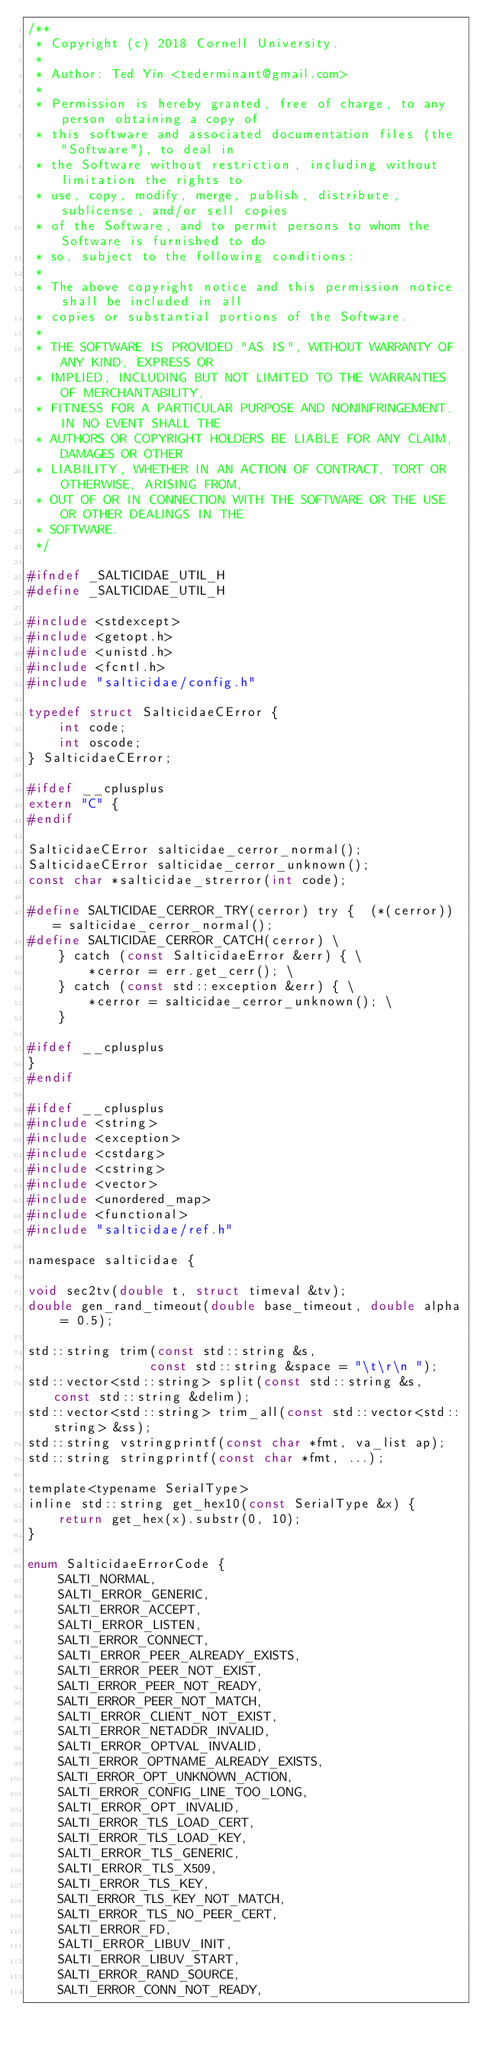Convert code to text. <code><loc_0><loc_0><loc_500><loc_500><_C_>/**
 * Copyright (c) 2018 Cornell University.
 *
 * Author: Ted Yin <tederminant@gmail.com>
 *
 * Permission is hereby granted, free of charge, to any person obtaining a copy of
 * this software and associated documentation files (the "Software"), to deal in
 * the Software without restriction, including without limitation the rights to
 * use, copy, modify, merge, publish, distribute, sublicense, and/or sell copies
 * of the Software, and to permit persons to whom the Software is furnished to do
 * so, subject to the following conditions:
 *
 * The above copyright notice and this permission notice shall be included in all
 * copies or substantial portions of the Software.
 *
 * THE SOFTWARE IS PROVIDED "AS IS", WITHOUT WARRANTY OF ANY KIND, EXPRESS OR
 * IMPLIED, INCLUDING BUT NOT LIMITED TO THE WARRANTIES OF MERCHANTABILITY,
 * FITNESS FOR A PARTICULAR PURPOSE AND NONINFRINGEMENT. IN NO EVENT SHALL THE
 * AUTHORS OR COPYRIGHT HOLDERS BE LIABLE FOR ANY CLAIM, DAMAGES OR OTHER
 * LIABILITY, WHETHER IN AN ACTION OF CONTRACT, TORT OR OTHERWISE, ARISING FROM,
 * OUT OF OR IN CONNECTION WITH THE SOFTWARE OR THE USE OR OTHER DEALINGS IN THE
 * SOFTWARE.
 */

#ifndef _SALTICIDAE_UTIL_H
#define _SALTICIDAE_UTIL_H

#include <stdexcept>
#include <getopt.h>
#include <unistd.h>
#include <fcntl.h>
#include "salticidae/config.h"

typedef struct SalticidaeCError {
    int code;
    int oscode;
} SalticidaeCError;

#ifdef __cplusplus
extern "C" {
#endif

SalticidaeCError salticidae_cerror_normal();
SalticidaeCError salticidae_cerror_unknown();
const char *salticidae_strerror(int code);

#define SALTICIDAE_CERROR_TRY(cerror) try {  (*(cerror)) = salticidae_cerror_normal();
#define SALTICIDAE_CERROR_CATCH(cerror) \
    } catch (const SalticidaeError &err) { \
        *cerror = err.get_cerr(); \
    } catch (const std::exception &err) { \
        *cerror = salticidae_cerror_unknown(); \
    }

#ifdef __cplusplus
}
#endif

#ifdef __cplusplus
#include <string>
#include <exception>
#include <cstdarg>
#include <cstring>
#include <vector>
#include <unordered_map>
#include <functional>
#include "salticidae/ref.h"

namespace salticidae {

void sec2tv(double t, struct timeval &tv);
double gen_rand_timeout(double base_timeout, double alpha = 0.5);

std::string trim(const std::string &s,
                const std::string &space = "\t\r\n ");
std::vector<std::string> split(const std::string &s, const std::string &delim);
std::vector<std::string> trim_all(const std::vector<std::string> &ss);
std::string vstringprintf(const char *fmt, va_list ap);
std::string stringprintf(const char *fmt, ...);

template<typename SerialType>
inline std::string get_hex10(const SerialType &x) {
    return get_hex(x).substr(0, 10);
}

enum SalticidaeErrorCode {
    SALTI_NORMAL,
    SALTI_ERROR_GENERIC,
    SALTI_ERROR_ACCEPT,
    SALTI_ERROR_LISTEN,
    SALTI_ERROR_CONNECT,
    SALTI_ERROR_PEER_ALREADY_EXISTS,
    SALTI_ERROR_PEER_NOT_EXIST,
    SALTI_ERROR_PEER_NOT_READY,
    SALTI_ERROR_PEER_NOT_MATCH,
    SALTI_ERROR_CLIENT_NOT_EXIST,
    SALTI_ERROR_NETADDR_INVALID,
    SALTI_ERROR_OPTVAL_INVALID,
    SALTI_ERROR_OPTNAME_ALREADY_EXISTS,
    SALTI_ERROR_OPT_UNKNOWN_ACTION,
    SALTI_ERROR_CONFIG_LINE_TOO_LONG,
    SALTI_ERROR_OPT_INVALID,
    SALTI_ERROR_TLS_LOAD_CERT,
    SALTI_ERROR_TLS_LOAD_KEY,
    SALTI_ERROR_TLS_GENERIC,
    SALTI_ERROR_TLS_X509,
    SALTI_ERROR_TLS_KEY,
    SALTI_ERROR_TLS_KEY_NOT_MATCH,
    SALTI_ERROR_TLS_NO_PEER_CERT,
    SALTI_ERROR_FD,
    SALTI_ERROR_LIBUV_INIT,
    SALTI_ERROR_LIBUV_START,
    SALTI_ERROR_RAND_SOURCE,
    SALTI_ERROR_CONN_NOT_READY,</code> 